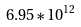<formula> <loc_0><loc_0><loc_500><loc_500>6 . 9 5 * 1 0 ^ { 1 2 }</formula> 